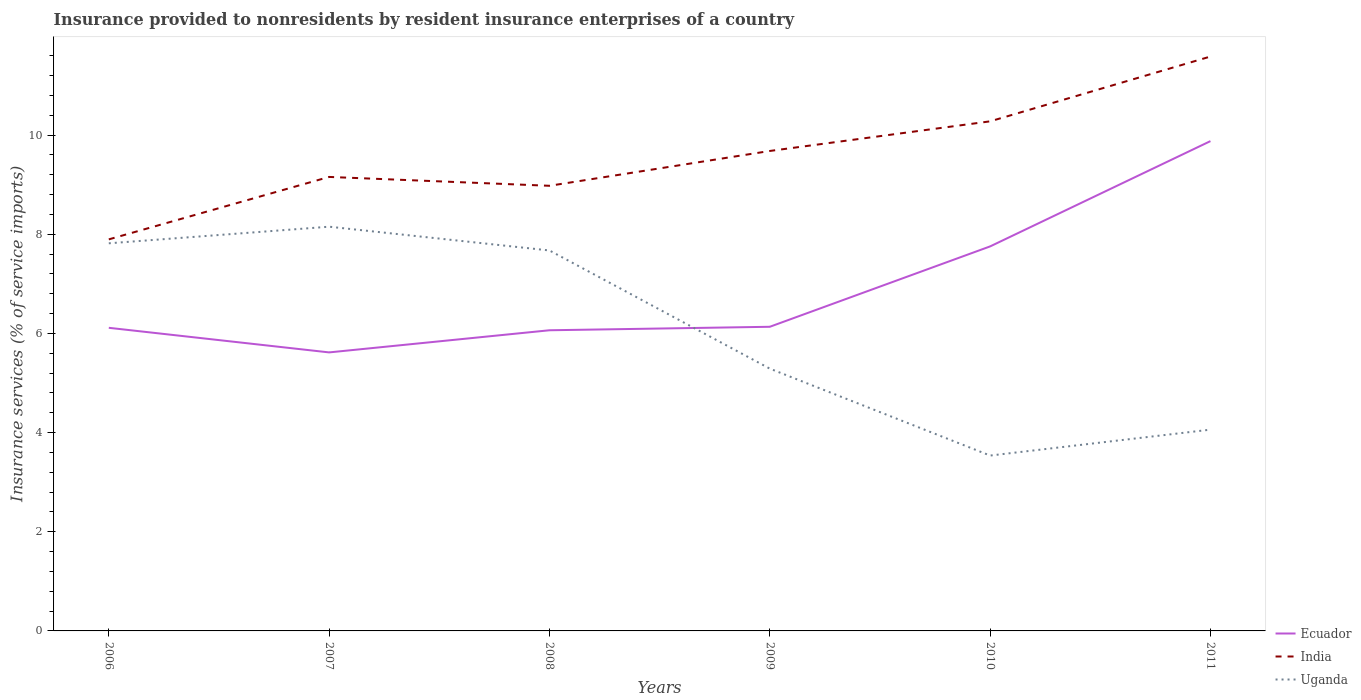Does the line corresponding to Uganda intersect with the line corresponding to Ecuador?
Provide a succinct answer. Yes. Is the number of lines equal to the number of legend labels?
Offer a terse response. Yes. Across all years, what is the maximum insurance provided to nonresidents in India?
Give a very brief answer. 7.9. In which year was the insurance provided to nonresidents in Uganda maximum?
Provide a succinct answer. 2010. What is the total insurance provided to nonresidents in India in the graph?
Provide a succinct answer. -2.38. What is the difference between the highest and the second highest insurance provided to nonresidents in Uganda?
Offer a very short reply. 4.62. Is the insurance provided to nonresidents in India strictly greater than the insurance provided to nonresidents in Ecuador over the years?
Keep it short and to the point. No. How many years are there in the graph?
Your response must be concise. 6. What is the difference between two consecutive major ticks on the Y-axis?
Your answer should be compact. 2. Does the graph contain grids?
Provide a succinct answer. No. What is the title of the graph?
Your response must be concise. Insurance provided to nonresidents by resident insurance enterprises of a country. What is the label or title of the Y-axis?
Your answer should be compact. Insurance services (% of service imports). What is the Insurance services (% of service imports) in Ecuador in 2006?
Your answer should be compact. 6.11. What is the Insurance services (% of service imports) of India in 2006?
Offer a terse response. 7.9. What is the Insurance services (% of service imports) in Uganda in 2006?
Give a very brief answer. 7.82. What is the Insurance services (% of service imports) of Ecuador in 2007?
Your response must be concise. 5.62. What is the Insurance services (% of service imports) of India in 2007?
Give a very brief answer. 9.16. What is the Insurance services (% of service imports) in Uganda in 2007?
Provide a short and direct response. 8.15. What is the Insurance services (% of service imports) in Ecuador in 2008?
Make the answer very short. 6.06. What is the Insurance services (% of service imports) in India in 2008?
Your answer should be compact. 8.98. What is the Insurance services (% of service imports) in Uganda in 2008?
Ensure brevity in your answer.  7.67. What is the Insurance services (% of service imports) in Ecuador in 2009?
Your answer should be very brief. 6.13. What is the Insurance services (% of service imports) in India in 2009?
Provide a succinct answer. 9.68. What is the Insurance services (% of service imports) in Uganda in 2009?
Provide a short and direct response. 5.29. What is the Insurance services (% of service imports) in Ecuador in 2010?
Keep it short and to the point. 7.76. What is the Insurance services (% of service imports) in India in 2010?
Offer a very short reply. 10.28. What is the Insurance services (% of service imports) in Uganda in 2010?
Offer a very short reply. 3.54. What is the Insurance services (% of service imports) in Ecuador in 2011?
Provide a succinct answer. 9.88. What is the Insurance services (% of service imports) in India in 2011?
Provide a short and direct response. 11.59. What is the Insurance services (% of service imports) in Uganda in 2011?
Ensure brevity in your answer.  4.06. Across all years, what is the maximum Insurance services (% of service imports) in Ecuador?
Offer a terse response. 9.88. Across all years, what is the maximum Insurance services (% of service imports) of India?
Provide a succinct answer. 11.59. Across all years, what is the maximum Insurance services (% of service imports) of Uganda?
Ensure brevity in your answer.  8.15. Across all years, what is the minimum Insurance services (% of service imports) in Ecuador?
Give a very brief answer. 5.62. Across all years, what is the minimum Insurance services (% of service imports) of India?
Ensure brevity in your answer.  7.9. Across all years, what is the minimum Insurance services (% of service imports) in Uganda?
Ensure brevity in your answer.  3.54. What is the total Insurance services (% of service imports) in Ecuador in the graph?
Your answer should be compact. 41.57. What is the total Insurance services (% of service imports) of India in the graph?
Make the answer very short. 57.58. What is the total Insurance services (% of service imports) of Uganda in the graph?
Your answer should be compact. 36.53. What is the difference between the Insurance services (% of service imports) of Ecuador in 2006 and that in 2007?
Ensure brevity in your answer.  0.5. What is the difference between the Insurance services (% of service imports) in India in 2006 and that in 2007?
Keep it short and to the point. -1.26. What is the difference between the Insurance services (% of service imports) of Uganda in 2006 and that in 2007?
Offer a terse response. -0.34. What is the difference between the Insurance services (% of service imports) of Ecuador in 2006 and that in 2008?
Offer a very short reply. 0.05. What is the difference between the Insurance services (% of service imports) in India in 2006 and that in 2008?
Your answer should be compact. -1.08. What is the difference between the Insurance services (% of service imports) in Uganda in 2006 and that in 2008?
Offer a terse response. 0.14. What is the difference between the Insurance services (% of service imports) in Ecuador in 2006 and that in 2009?
Ensure brevity in your answer.  -0.02. What is the difference between the Insurance services (% of service imports) of India in 2006 and that in 2009?
Offer a very short reply. -1.78. What is the difference between the Insurance services (% of service imports) in Uganda in 2006 and that in 2009?
Offer a very short reply. 2.53. What is the difference between the Insurance services (% of service imports) in Ecuador in 2006 and that in 2010?
Keep it short and to the point. -1.64. What is the difference between the Insurance services (% of service imports) in India in 2006 and that in 2010?
Offer a very short reply. -2.38. What is the difference between the Insurance services (% of service imports) in Uganda in 2006 and that in 2010?
Offer a very short reply. 4.28. What is the difference between the Insurance services (% of service imports) of Ecuador in 2006 and that in 2011?
Ensure brevity in your answer.  -3.77. What is the difference between the Insurance services (% of service imports) of India in 2006 and that in 2011?
Provide a succinct answer. -3.69. What is the difference between the Insurance services (% of service imports) in Uganda in 2006 and that in 2011?
Give a very brief answer. 3.76. What is the difference between the Insurance services (% of service imports) of Ecuador in 2007 and that in 2008?
Offer a very short reply. -0.45. What is the difference between the Insurance services (% of service imports) of India in 2007 and that in 2008?
Provide a short and direct response. 0.18. What is the difference between the Insurance services (% of service imports) of Uganda in 2007 and that in 2008?
Ensure brevity in your answer.  0.48. What is the difference between the Insurance services (% of service imports) in Ecuador in 2007 and that in 2009?
Provide a succinct answer. -0.52. What is the difference between the Insurance services (% of service imports) of India in 2007 and that in 2009?
Make the answer very short. -0.52. What is the difference between the Insurance services (% of service imports) in Uganda in 2007 and that in 2009?
Your answer should be compact. 2.86. What is the difference between the Insurance services (% of service imports) of Ecuador in 2007 and that in 2010?
Your answer should be compact. -2.14. What is the difference between the Insurance services (% of service imports) in India in 2007 and that in 2010?
Offer a very short reply. -1.12. What is the difference between the Insurance services (% of service imports) in Uganda in 2007 and that in 2010?
Ensure brevity in your answer.  4.62. What is the difference between the Insurance services (% of service imports) in Ecuador in 2007 and that in 2011?
Your response must be concise. -4.26. What is the difference between the Insurance services (% of service imports) in India in 2007 and that in 2011?
Your answer should be very brief. -2.43. What is the difference between the Insurance services (% of service imports) in Uganda in 2007 and that in 2011?
Your answer should be compact. 4.09. What is the difference between the Insurance services (% of service imports) in Ecuador in 2008 and that in 2009?
Keep it short and to the point. -0.07. What is the difference between the Insurance services (% of service imports) of India in 2008 and that in 2009?
Your answer should be very brief. -0.7. What is the difference between the Insurance services (% of service imports) of Uganda in 2008 and that in 2009?
Your answer should be compact. 2.38. What is the difference between the Insurance services (% of service imports) of Ecuador in 2008 and that in 2010?
Keep it short and to the point. -1.69. What is the difference between the Insurance services (% of service imports) in India in 2008 and that in 2010?
Your answer should be very brief. -1.3. What is the difference between the Insurance services (% of service imports) in Uganda in 2008 and that in 2010?
Give a very brief answer. 4.14. What is the difference between the Insurance services (% of service imports) in Ecuador in 2008 and that in 2011?
Provide a short and direct response. -3.82. What is the difference between the Insurance services (% of service imports) of India in 2008 and that in 2011?
Ensure brevity in your answer.  -2.61. What is the difference between the Insurance services (% of service imports) of Uganda in 2008 and that in 2011?
Your response must be concise. 3.61. What is the difference between the Insurance services (% of service imports) of Ecuador in 2009 and that in 2010?
Your response must be concise. -1.62. What is the difference between the Insurance services (% of service imports) of India in 2009 and that in 2010?
Ensure brevity in your answer.  -0.6. What is the difference between the Insurance services (% of service imports) of Uganda in 2009 and that in 2010?
Your answer should be very brief. 1.75. What is the difference between the Insurance services (% of service imports) of Ecuador in 2009 and that in 2011?
Offer a very short reply. -3.74. What is the difference between the Insurance services (% of service imports) in India in 2009 and that in 2011?
Keep it short and to the point. -1.9. What is the difference between the Insurance services (% of service imports) of Uganda in 2009 and that in 2011?
Keep it short and to the point. 1.23. What is the difference between the Insurance services (% of service imports) of Ecuador in 2010 and that in 2011?
Your answer should be very brief. -2.12. What is the difference between the Insurance services (% of service imports) of India in 2010 and that in 2011?
Keep it short and to the point. -1.31. What is the difference between the Insurance services (% of service imports) in Uganda in 2010 and that in 2011?
Your response must be concise. -0.52. What is the difference between the Insurance services (% of service imports) of Ecuador in 2006 and the Insurance services (% of service imports) of India in 2007?
Keep it short and to the point. -3.04. What is the difference between the Insurance services (% of service imports) in Ecuador in 2006 and the Insurance services (% of service imports) in Uganda in 2007?
Your answer should be very brief. -2.04. What is the difference between the Insurance services (% of service imports) of India in 2006 and the Insurance services (% of service imports) of Uganda in 2007?
Ensure brevity in your answer.  -0.26. What is the difference between the Insurance services (% of service imports) in Ecuador in 2006 and the Insurance services (% of service imports) in India in 2008?
Ensure brevity in your answer.  -2.86. What is the difference between the Insurance services (% of service imports) in Ecuador in 2006 and the Insurance services (% of service imports) in Uganda in 2008?
Make the answer very short. -1.56. What is the difference between the Insurance services (% of service imports) in India in 2006 and the Insurance services (% of service imports) in Uganda in 2008?
Offer a very short reply. 0.22. What is the difference between the Insurance services (% of service imports) of Ecuador in 2006 and the Insurance services (% of service imports) of India in 2009?
Ensure brevity in your answer.  -3.57. What is the difference between the Insurance services (% of service imports) of Ecuador in 2006 and the Insurance services (% of service imports) of Uganda in 2009?
Your answer should be compact. 0.82. What is the difference between the Insurance services (% of service imports) of India in 2006 and the Insurance services (% of service imports) of Uganda in 2009?
Your response must be concise. 2.61. What is the difference between the Insurance services (% of service imports) of Ecuador in 2006 and the Insurance services (% of service imports) of India in 2010?
Provide a succinct answer. -4.16. What is the difference between the Insurance services (% of service imports) in Ecuador in 2006 and the Insurance services (% of service imports) in Uganda in 2010?
Give a very brief answer. 2.58. What is the difference between the Insurance services (% of service imports) in India in 2006 and the Insurance services (% of service imports) in Uganda in 2010?
Ensure brevity in your answer.  4.36. What is the difference between the Insurance services (% of service imports) in Ecuador in 2006 and the Insurance services (% of service imports) in India in 2011?
Offer a very short reply. -5.47. What is the difference between the Insurance services (% of service imports) of Ecuador in 2006 and the Insurance services (% of service imports) of Uganda in 2011?
Keep it short and to the point. 2.05. What is the difference between the Insurance services (% of service imports) in India in 2006 and the Insurance services (% of service imports) in Uganda in 2011?
Provide a short and direct response. 3.84. What is the difference between the Insurance services (% of service imports) in Ecuador in 2007 and the Insurance services (% of service imports) in India in 2008?
Make the answer very short. -3.36. What is the difference between the Insurance services (% of service imports) of Ecuador in 2007 and the Insurance services (% of service imports) of Uganda in 2008?
Keep it short and to the point. -2.06. What is the difference between the Insurance services (% of service imports) in India in 2007 and the Insurance services (% of service imports) in Uganda in 2008?
Provide a succinct answer. 1.48. What is the difference between the Insurance services (% of service imports) in Ecuador in 2007 and the Insurance services (% of service imports) in India in 2009?
Offer a terse response. -4.06. What is the difference between the Insurance services (% of service imports) of Ecuador in 2007 and the Insurance services (% of service imports) of Uganda in 2009?
Offer a terse response. 0.33. What is the difference between the Insurance services (% of service imports) in India in 2007 and the Insurance services (% of service imports) in Uganda in 2009?
Make the answer very short. 3.87. What is the difference between the Insurance services (% of service imports) in Ecuador in 2007 and the Insurance services (% of service imports) in India in 2010?
Offer a terse response. -4.66. What is the difference between the Insurance services (% of service imports) in Ecuador in 2007 and the Insurance services (% of service imports) in Uganda in 2010?
Your answer should be very brief. 2.08. What is the difference between the Insurance services (% of service imports) of India in 2007 and the Insurance services (% of service imports) of Uganda in 2010?
Offer a very short reply. 5.62. What is the difference between the Insurance services (% of service imports) of Ecuador in 2007 and the Insurance services (% of service imports) of India in 2011?
Your answer should be compact. -5.97. What is the difference between the Insurance services (% of service imports) of Ecuador in 2007 and the Insurance services (% of service imports) of Uganda in 2011?
Your answer should be very brief. 1.56. What is the difference between the Insurance services (% of service imports) of India in 2007 and the Insurance services (% of service imports) of Uganda in 2011?
Your answer should be very brief. 5.1. What is the difference between the Insurance services (% of service imports) in Ecuador in 2008 and the Insurance services (% of service imports) in India in 2009?
Make the answer very short. -3.62. What is the difference between the Insurance services (% of service imports) in Ecuador in 2008 and the Insurance services (% of service imports) in Uganda in 2009?
Make the answer very short. 0.77. What is the difference between the Insurance services (% of service imports) of India in 2008 and the Insurance services (% of service imports) of Uganda in 2009?
Provide a succinct answer. 3.69. What is the difference between the Insurance services (% of service imports) in Ecuador in 2008 and the Insurance services (% of service imports) in India in 2010?
Offer a very short reply. -4.21. What is the difference between the Insurance services (% of service imports) of Ecuador in 2008 and the Insurance services (% of service imports) of Uganda in 2010?
Provide a succinct answer. 2.53. What is the difference between the Insurance services (% of service imports) of India in 2008 and the Insurance services (% of service imports) of Uganda in 2010?
Give a very brief answer. 5.44. What is the difference between the Insurance services (% of service imports) of Ecuador in 2008 and the Insurance services (% of service imports) of India in 2011?
Ensure brevity in your answer.  -5.52. What is the difference between the Insurance services (% of service imports) of Ecuador in 2008 and the Insurance services (% of service imports) of Uganda in 2011?
Give a very brief answer. 2. What is the difference between the Insurance services (% of service imports) in India in 2008 and the Insurance services (% of service imports) in Uganda in 2011?
Make the answer very short. 4.92. What is the difference between the Insurance services (% of service imports) of Ecuador in 2009 and the Insurance services (% of service imports) of India in 2010?
Give a very brief answer. -4.14. What is the difference between the Insurance services (% of service imports) of Ecuador in 2009 and the Insurance services (% of service imports) of Uganda in 2010?
Provide a succinct answer. 2.6. What is the difference between the Insurance services (% of service imports) in India in 2009 and the Insurance services (% of service imports) in Uganda in 2010?
Give a very brief answer. 6.14. What is the difference between the Insurance services (% of service imports) of Ecuador in 2009 and the Insurance services (% of service imports) of India in 2011?
Make the answer very short. -5.45. What is the difference between the Insurance services (% of service imports) in Ecuador in 2009 and the Insurance services (% of service imports) in Uganda in 2011?
Provide a short and direct response. 2.07. What is the difference between the Insurance services (% of service imports) of India in 2009 and the Insurance services (% of service imports) of Uganda in 2011?
Make the answer very short. 5.62. What is the difference between the Insurance services (% of service imports) in Ecuador in 2010 and the Insurance services (% of service imports) in India in 2011?
Give a very brief answer. -3.83. What is the difference between the Insurance services (% of service imports) in Ecuador in 2010 and the Insurance services (% of service imports) in Uganda in 2011?
Keep it short and to the point. 3.7. What is the difference between the Insurance services (% of service imports) of India in 2010 and the Insurance services (% of service imports) of Uganda in 2011?
Your response must be concise. 6.22. What is the average Insurance services (% of service imports) in Ecuador per year?
Provide a short and direct response. 6.93. What is the average Insurance services (% of service imports) of India per year?
Your response must be concise. 9.6. What is the average Insurance services (% of service imports) in Uganda per year?
Give a very brief answer. 6.09. In the year 2006, what is the difference between the Insurance services (% of service imports) in Ecuador and Insurance services (% of service imports) in India?
Provide a succinct answer. -1.78. In the year 2006, what is the difference between the Insurance services (% of service imports) of Ecuador and Insurance services (% of service imports) of Uganda?
Make the answer very short. -1.7. In the year 2006, what is the difference between the Insurance services (% of service imports) of India and Insurance services (% of service imports) of Uganda?
Your response must be concise. 0.08. In the year 2007, what is the difference between the Insurance services (% of service imports) in Ecuador and Insurance services (% of service imports) in India?
Your answer should be very brief. -3.54. In the year 2007, what is the difference between the Insurance services (% of service imports) of Ecuador and Insurance services (% of service imports) of Uganda?
Provide a short and direct response. -2.54. In the year 2007, what is the difference between the Insurance services (% of service imports) in India and Insurance services (% of service imports) in Uganda?
Your answer should be very brief. 1. In the year 2008, what is the difference between the Insurance services (% of service imports) of Ecuador and Insurance services (% of service imports) of India?
Offer a very short reply. -2.91. In the year 2008, what is the difference between the Insurance services (% of service imports) of Ecuador and Insurance services (% of service imports) of Uganda?
Offer a very short reply. -1.61. In the year 2008, what is the difference between the Insurance services (% of service imports) of India and Insurance services (% of service imports) of Uganda?
Provide a short and direct response. 1.3. In the year 2009, what is the difference between the Insurance services (% of service imports) in Ecuador and Insurance services (% of service imports) in India?
Offer a very short reply. -3.55. In the year 2009, what is the difference between the Insurance services (% of service imports) in Ecuador and Insurance services (% of service imports) in Uganda?
Give a very brief answer. 0.84. In the year 2009, what is the difference between the Insurance services (% of service imports) in India and Insurance services (% of service imports) in Uganda?
Your response must be concise. 4.39. In the year 2010, what is the difference between the Insurance services (% of service imports) of Ecuador and Insurance services (% of service imports) of India?
Give a very brief answer. -2.52. In the year 2010, what is the difference between the Insurance services (% of service imports) in Ecuador and Insurance services (% of service imports) in Uganda?
Ensure brevity in your answer.  4.22. In the year 2010, what is the difference between the Insurance services (% of service imports) in India and Insurance services (% of service imports) in Uganda?
Your answer should be very brief. 6.74. In the year 2011, what is the difference between the Insurance services (% of service imports) in Ecuador and Insurance services (% of service imports) in India?
Ensure brevity in your answer.  -1.71. In the year 2011, what is the difference between the Insurance services (% of service imports) in Ecuador and Insurance services (% of service imports) in Uganda?
Give a very brief answer. 5.82. In the year 2011, what is the difference between the Insurance services (% of service imports) of India and Insurance services (% of service imports) of Uganda?
Provide a succinct answer. 7.53. What is the ratio of the Insurance services (% of service imports) in Ecuador in 2006 to that in 2007?
Ensure brevity in your answer.  1.09. What is the ratio of the Insurance services (% of service imports) in India in 2006 to that in 2007?
Your answer should be very brief. 0.86. What is the ratio of the Insurance services (% of service imports) of Uganda in 2006 to that in 2007?
Provide a succinct answer. 0.96. What is the ratio of the Insurance services (% of service imports) of Ecuador in 2006 to that in 2008?
Provide a succinct answer. 1.01. What is the ratio of the Insurance services (% of service imports) in India in 2006 to that in 2008?
Your answer should be very brief. 0.88. What is the ratio of the Insurance services (% of service imports) in Uganda in 2006 to that in 2008?
Your response must be concise. 1.02. What is the ratio of the Insurance services (% of service imports) in Ecuador in 2006 to that in 2009?
Your answer should be very brief. 1. What is the ratio of the Insurance services (% of service imports) in India in 2006 to that in 2009?
Your response must be concise. 0.82. What is the ratio of the Insurance services (% of service imports) in Uganda in 2006 to that in 2009?
Make the answer very short. 1.48. What is the ratio of the Insurance services (% of service imports) in Ecuador in 2006 to that in 2010?
Make the answer very short. 0.79. What is the ratio of the Insurance services (% of service imports) in India in 2006 to that in 2010?
Your answer should be very brief. 0.77. What is the ratio of the Insurance services (% of service imports) of Uganda in 2006 to that in 2010?
Provide a succinct answer. 2.21. What is the ratio of the Insurance services (% of service imports) in Ecuador in 2006 to that in 2011?
Ensure brevity in your answer.  0.62. What is the ratio of the Insurance services (% of service imports) of India in 2006 to that in 2011?
Your answer should be compact. 0.68. What is the ratio of the Insurance services (% of service imports) of Uganda in 2006 to that in 2011?
Offer a terse response. 1.93. What is the ratio of the Insurance services (% of service imports) in Ecuador in 2007 to that in 2008?
Offer a terse response. 0.93. What is the ratio of the Insurance services (% of service imports) of India in 2007 to that in 2008?
Ensure brevity in your answer.  1.02. What is the ratio of the Insurance services (% of service imports) in Uganda in 2007 to that in 2008?
Provide a short and direct response. 1.06. What is the ratio of the Insurance services (% of service imports) in Ecuador in 2007 to that in 2009?
Provide a short and direct response. 0.92. What is the ratio of the Insurance services (% of service imports) in India in 2007 to that in 2009?
Provide a short and direct response. 0.95. What is the ratio of the Insurance services (% of service imports) in Uganda in 2007 to that in 2009?
Offer a very short reply. 1.54. What is the ratio of the Insurance services (% of service imports) in Ecuador in 2007 to that in 2010?
Provide a succinct answer. 0.72. What is the ratio of the Insurance services (% of service imports) of India in 2007 to that in 2010?
Give a very brief answer. 0.89. What is the ratio of the Insurance services (% of service imports) of Uganda in 2007 to that in 2010?
Your response must be concise. 2.31. What is the ratio of the Insurance services (% of service imports) in Ecuador in 2007 to that in 2011?
Give a very brief answer. 0.57. What is the ratio of the Insurance services (% of service imports) of India in 2007 to that in 2011?
Your answer should be very brief. 0.79. What is the ratio of the Insurance services (% of service imports) in Uganda in 2007 to that in 2011?
Provide a short and direct response. 2.01. What is the ratio of the Insurance services (% of service imports) of Ecuador in 2008 to that in 2009?
Provide a succinct answer. 0.99. What is the ratio of the Insurance services (% of service imports) in India in 2008 to that in 2009?
Keep it short and to the point. 0.93. What is the ratio of the Insurance services (% of service imports) of Uganda in 2008 to that in 2009?
Keep it short and to the point. 1.45. What is the ratio of the Insurance services (% of service imports) in Ecuador in 2008 to that in 2010?
Ensure brevity in your answer.  0.78. What is the ratio of the Insurance services (% of service imports) of India in 2008 to that in 2010?
Give a very brief answer. 0.87. What is the ratio of the Insurance services (% of service imports) of Uganda in 2008 to that in 2010?
Your answer should be compact. 2.17. What is the ratio of the Insurance services (% of service imports) of Ecuador in 2008 to that in 2011?
Your answer should be very brief. 0.61. What is the ratio of the Insurance services (% of service imports) of India in 2008 to that in 2011?
Offer a very short reply. 0.78. What is the ratio of the Insurance services (% of service imports) of Uganda in 2008 to that in 2011?
Your answer should be compact. 1.89. What is the ratio of the Insurance services (% of service imports) in Ecuador in 2009 to that in 2010?
Your response must be concise. 0.79. What is the ratio of the Insurance services (% of service imports) of India in 2009 to that in 2010?
Your response must be concise. 0.94. What is the ratio of the Insurance services (% of service imports) in Uganda in 2009 to that in 2010?
Keep it short and to the point. 1.5. What is the ratio of the Insurance services (% of service imports) in Ecuador in 2009 to that in 2011?
Offer a terse response. 0.62. What is the ratio of the Insurance services (% of service imports) of India in 2009 to that in 2011?
Offer a terse response. 0.84. What is the ratio of the Insurance services (% of service imports) of Uganda in 2009 to that in 2011?
Ensure brevity in your answer.  1.3. What is the ratio of the Insurance services (% of service imports) of Ecuador in 2010 to that in 2011?
Ensure brevity in your answer.  0.79. What is the ratio of the Insurance services (% of service imports) of India in 2010 to that in 2011?
Your response must be concise. 0.89. What is the ratio of the Insurance services (% of service imports) of Uganda in 2010 to that in 2011?
Make the answer very short. 0.87. What is the difference between the highest and the second highest Insurance services (% of service imports) in Ecuador?
Keep it short and to the point. 2.12. What is the difference between the highest and the second highest Insurance services (% of service imports) of India?
Offer a very short reply. 1.31. What is the difference between the highest and the second highest Insurance services (% of service imports) in Uganda?
Offer a very short reply. 0.34. What is the difference between the highest and the lowest Insurance services (% of service imports) of Ecuador?
Offer a terse response. 4.26. What is the difference between the highest and the lowest Insurance services (% of service imports) in India?
Make the answer very short. 3.69. What is the difference between the highest and the lowest Insurance services (% of service imports) in Uganda?
Your answer should be compact. 4.62. 